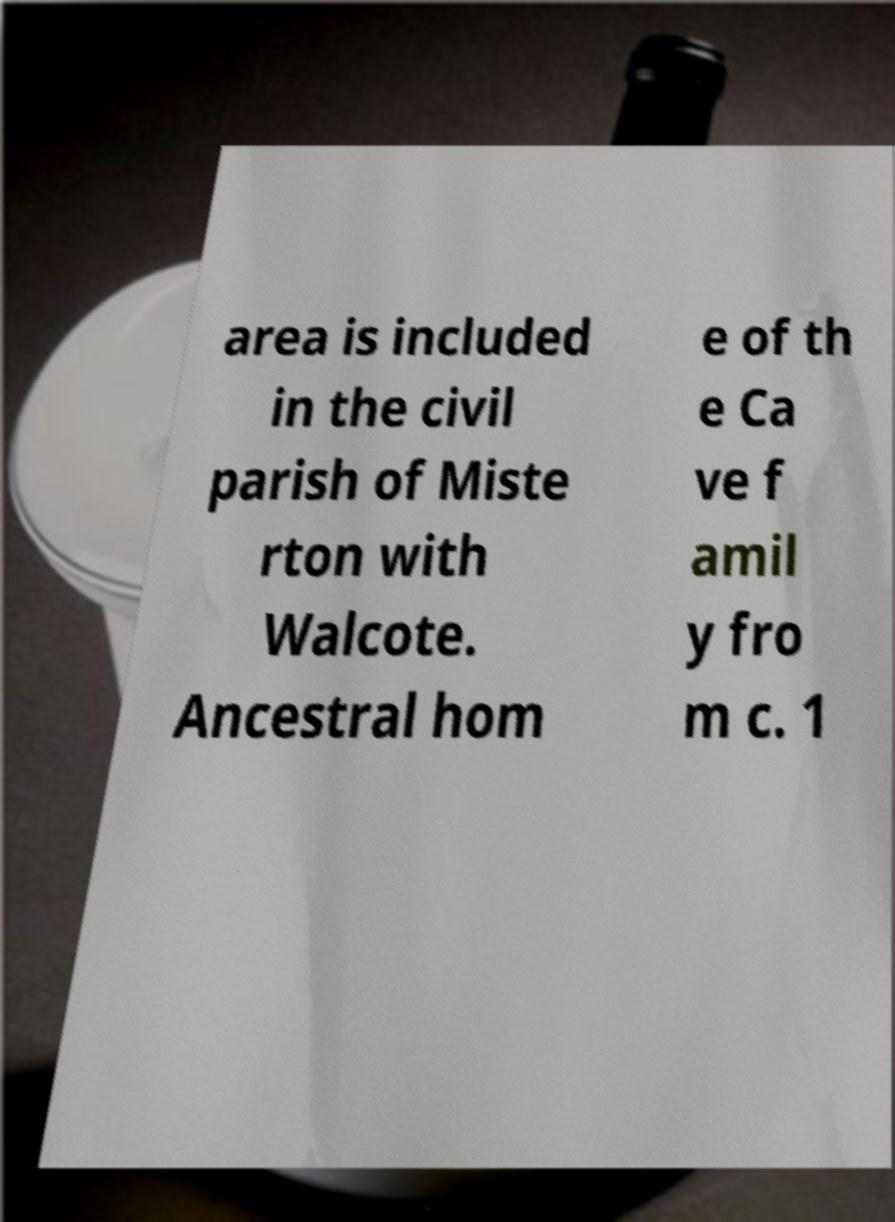I need the written content from this picture converted into text. Can you do that? area is included in the civil parish of Miste rton with Walcote. Ancestral hom e of th e Ca ve f amil y fro m c. 1 